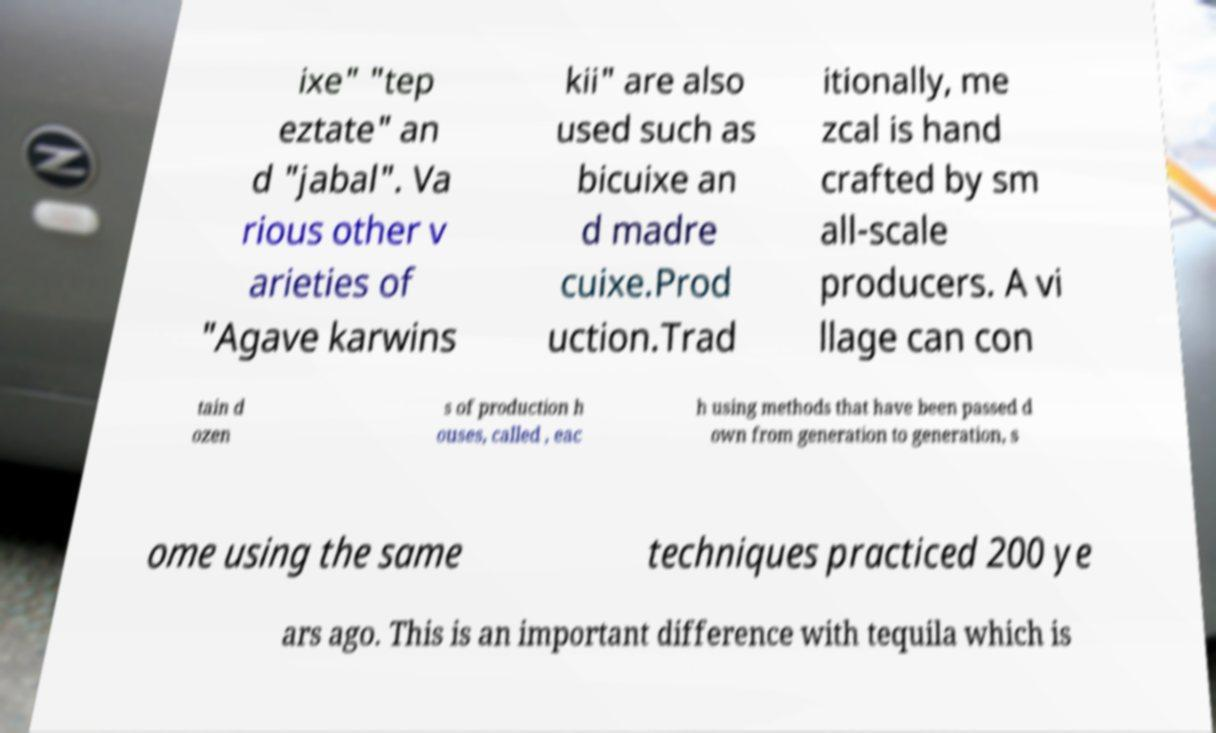What messages or text are displayed in this image? I need them in a readable, typed format. ixe" "tep eztate" an d "jabal". Va rious other v arieties of "Agave karwins kii" are also used such as bicuixe an d madre cuixe.Prod uction.Trad itionally, me zcal is hand crafted by sm all-scale producers. A vi llage can con tain d ozen s of production h ouses, called , eac h using methods that have been passed d own from generation to generation, s ome using the same techniques practiced 200 ye ars ago. This is an important difference with tequila which is 